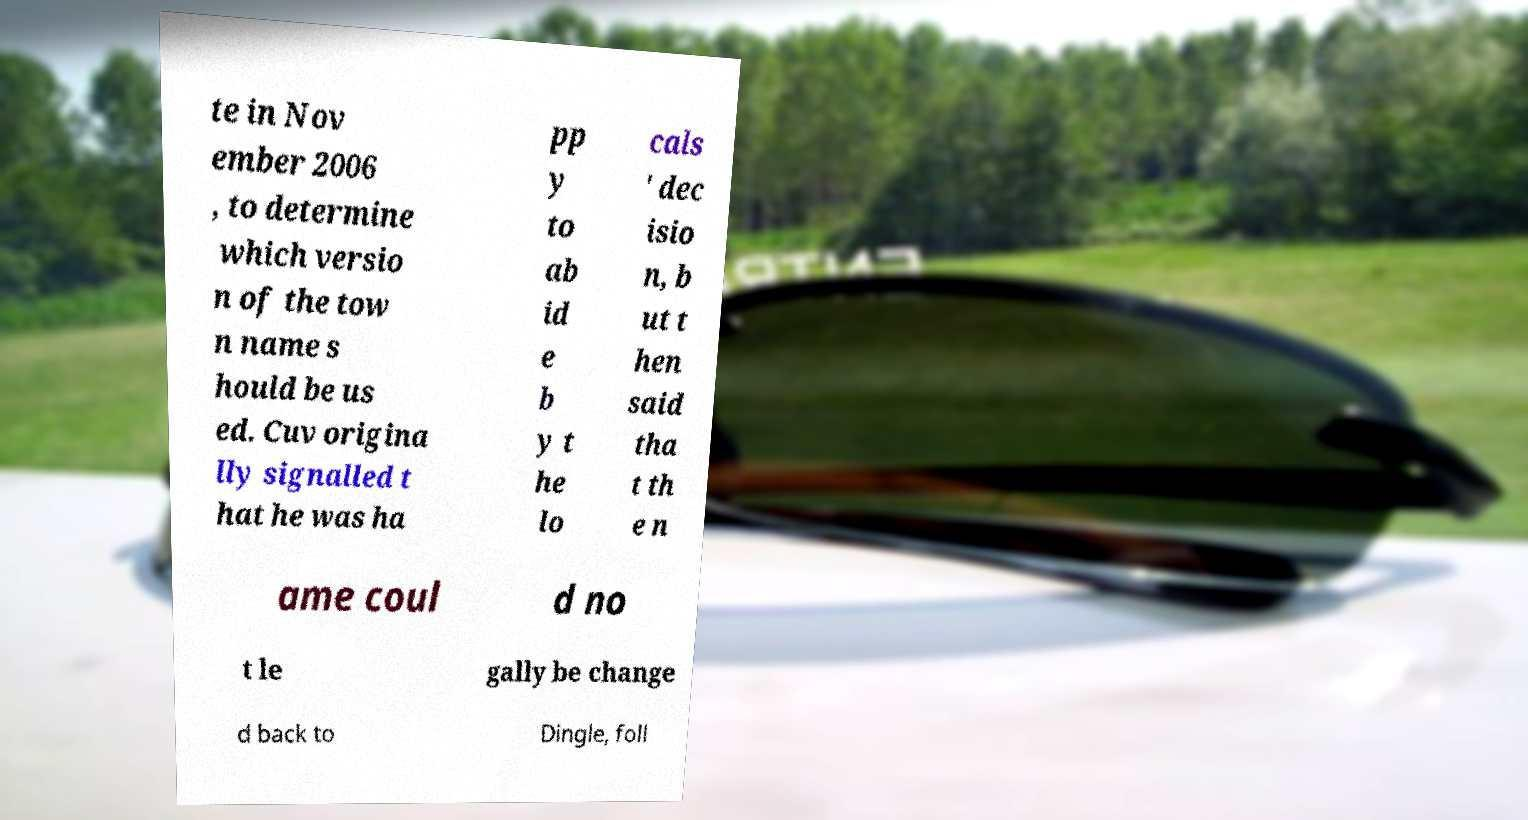Could you assist in decoding the text presented in this image and type it out clearly? te in Nov ember 2006 , to determine which versio n of the tow n name s hould be us ed. Cuv origina lly signalled t hat he was ha pp y to ab id e b y t he lo cals ' dec isio n, b ut t hen said tha t th e n ame coul d no t le gally be change d back to Dingle, foll 